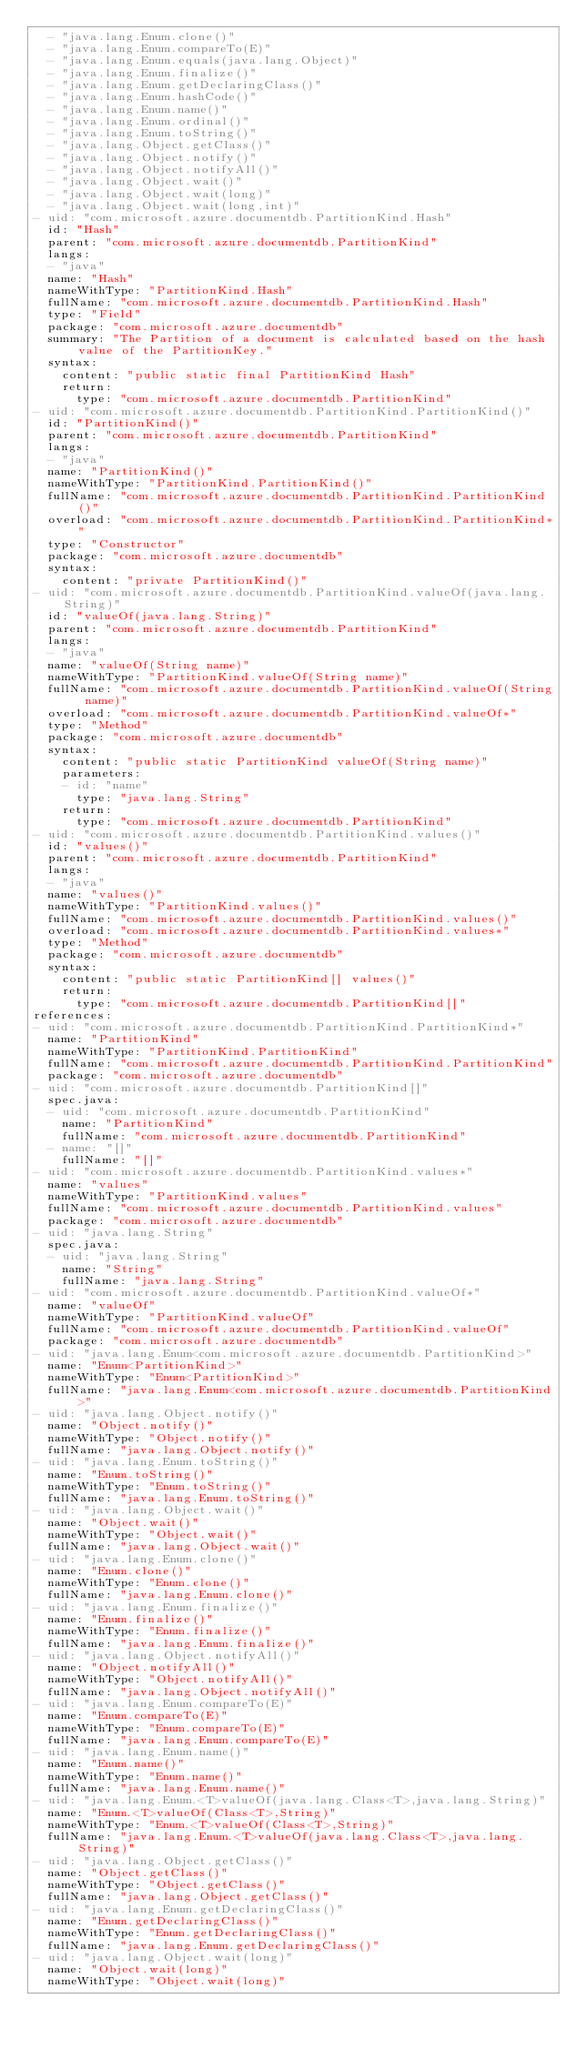<code> <loc_0><loc_0><loc_500><loc_500><_YAML_>  - "java.lang.Enum.clone()"
  - "java.lang.Enum.compareTo(E)"
  - "java.lang.Enum.equals(java.lang.Object)"
  - "java.lang.Enum.finalize()"
  - "java.lang.Enum.getDeclaringClass()"
  - "java.lang.Enum.hashCode()"
  - "java.lang.Enum.name()"
  - "java.lang.Enum.ordinal()"
  - "java.lang.Enum.toString()"
  - "java.lang.Object.getClass()"
  - "java.lang.Object.notify()"
  - "java.lang.Object.notifyAll()"
  - "java.lang.Object.wait()"
  - "java.lang.Object.wait(long)"
  - "java.lang.Object.wait(long,int)"
- uid: "com.microsoft.azure.documentdb.PartitionKind.Hash"
  id: "Hash"
  parent: "com.microsoft.azure.documentdb.PartitionKind"
  langs:
  - "java"
  name: "Hash"
  nameWithType: "PartitionKind.Hash"
  fullName: "com.microsoft.azure.documentdb.PartitionKind.Hash"
  type: "Field"
  package: "com.microsoft.azure.documentdb"
  summary: "The Partition of a document is calculated based on the hash value of the PartitionKey."
  syntax:
    content: "public static final PartitionKind Hash"
    return:
      type: "com.microsoft.azure.documentdb.PartitionKind"
- uid: "com.microsoft.azure.documentdb.PartitionKind.PartitionKind()"
  id: "PartitionKind()"
  parent: "com.microsoft.azure.documentdb.PartitionKind"
  langs:
  - "java"
  name: "PartitionKind()"
  nameWithType: "PartitionKind.PartitionKind()"
  fullName: "com.microsoft.azure.documentdb.PartitionKind.PartitionKind()"
  overload: "com.microsoft.azure.documentdb.PartitionKind.PartitionKind*"
  type: "Constructor"
  package: "com.microsoft.azure.documentdb"
  syntax:
    content: "private PartitionKind()"
- uid: "com.microsoft.azure.documentdb.PartitionKind.valueOf(java.lang.String)"
  id: "valueOf(java.lang.String)"
  parent: "com.microsoft.azure.documentdb.PartitionKind"
  langs:
  - "java"
  name: "valueOf(String name)"
  nameWithType: "PartitionKind.valueOf(String name)"
  fullName: "com.microsoft.azure.documentdb.PartitionKind.valueOf(String name)"
  overload: "com.microsoft.azure.documentdb.PartitionKind.valueOf*"
  type: "Method"
  package: "com.microsoft.azure.documentdb"
  syntax:
    content: "public static PartitionKind valueOf(String name)"
    parameters:
    - id: "name"
      type: "java.lang.String"
    return:
      type: "com.microsoft.azure.documentdb.PartitionKind"
- uid: "com.microsoft.azure.documentdb.PartitionKind.values()"
  id: "values()"
  parent: "com.microsoft.azure.documentdb.PartitionKind"
  langs:
  - "java"
  name: "values()"
  nameWithType: "PartitionKind.values()"
  fullName: "com.microsoft.azure.documentdb.PartitionKind.values()"
  overload: "com.microsoft.azure.documentdb.PartitionKind.values*"
  type: "Method"
  package: "com.microsoft.azure.documentdb"
  syntax:
    content: "public static PartitionKind[] values()"
    return:
      type: "com.microsoft.azure.documentdb.PartitionKind[]"
references:
- uid: "com.microsoft.azure.documentdb.PartitionKind.PartitionKind*"
  name: "PartitionKind"
  nameWithType: "PartitionKind.PartitionKind"
  fullName: "com.microsoft.azure.documentdb.PartitionKind.PartitionKind"
  package: "com.microsoft.azure.documentdb"
- uid: "com.microsoft.azure.documentdb.PartitionKind[]"
  spec.java:
  - uid: "com.microsoft.azure.documentdb.PartitionKind"
    name: "PartitionKind"
    fullName: "com.microsoft.azure.documentdb.PartitionKind"
  - name: "[]"
    fullName: "[]"
- uid: "com.microsoft.azure.documentdb.PartitionKind.values*"
  name: "values"
  nameWithType: "PartitionKind.values"
  fullName: "com.microsoft.azure.documentdb.PartitionKind.values"
  package: "com.microsoft.azure.documentdb"
- uid: "java.lang.String"
  spec.java:
  - uid: "java.lang.String"
    name: "String"
    fullName: "java.lang.String"
- uid: "com.microsoft.azure.documentdb.PartitionKind.valueOf*"
  name: "valueOf"
  nameWithType: "PartitionKind.valueOf"
  fullName: "com.microsoft.azure.documentdb.PartitionKind.valueOf"
  package: "com.microsoft.azure.documentdb"
- uid: "java.lang.Enum<com.microsoft.azure.documentdb.PartitionKind>"
  name: "Enum<PartitionKind>"
  nameWithType: "Enum<PartitionKind>"
  fullName: "java.lang.Enum<com.microsoft.azure.documentdb.PartitionKind>"
- uid: "java.lang.Object.notify()"
  name: "Object.notify()"
  nameWithType: "Object.notify()"
  fullName: "java.lang.Object.notify()"
- uid: "java.lang.Enum.toString()"
  name: "Enum.toString()"
  nameWithType: "Enum.toString()"
  fullName: "java.lang.Enum.toString()"
- uid: "java.lang.Object.wait()"
  name: "Object.wait()"
  nameWithType: "Object.wait()"
  fullName: "java.lang.Object.wait()"
- uid: "java.lang.Enum.clone()"
  name: "Enum.clone()"
  nameWithType: "Enum.clone()"
  fullName: "java.lang.Enum.clone()"
- uid: "java.lang.Enum.finalize()"
  name: "Enum.finalize()"
  nameWithType: "Enum.finalize()"
  fullName: "java.lang.Enum.finalize()"
- uid: "java.lang.Object.notifyAll()"
  name: "Object.notifyAll()"
  nameWithType: "Object.notifyAll()"
  fullName: "java.lang.Object.notifyAll()"
- uid: "java.lang.Enum.compareTo(E)"
  name: "Enum.compareTo(E)"
  nameWithType: "Enum.compareTo(E)"
  fullName: "java.lang.Enum.compareTo(E)"
- uid: "java.lang.Enum.name()"
  name: "Enum.name()"
  nameWithType: "Enum.name()"
  fullName: "java.lang.Enum.name()"
- uid: "java.lang.Enum.<T>valueOf(java.lang.Class<T>,java.lang.String)"
  name: "Enum.<T>valueOf(Class<T>,String)"
  nameWithType: "Enum.<T>valueOf(Class<T>,String)"
  fullName: "java.lang.Enum.<T>valueOf(java.lang.Class<T>,java.lang.String)"
- uid: "java.lang.Object.getClass()"
  name: "Object.getClass()"
  nameWithType: "Object.getClass()"
  fullName: "java.lang.Object.getClass()"
- uid: "java.lang.Enum.getDeclaringClass()"
  name: "Enum.getDeclaringClass()"
  nameWithType: "Enum.getDeclaringClass()"
  fullName: "java.lang.Enum.getDeclaringClass()"
- uid: "java.lang.Object.wait(long)"
  name: "Object.wait(long)"
  nameWithType: "Object.wait(long)"</code> 